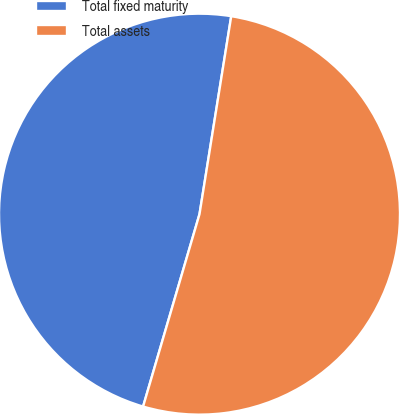Convert chart to OTSL. <chart><loc_0><loc_0><loc_500><loc_500><pie_chart><fcel>Total fixed maturity<fcel>Total assets<nl><fcel>47.99%<fcel>52.01%<nl></chart> 